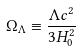Convert formula to latex. <formula><loc_0><loc_0><loc_500><loc_500>\Omega _ { \Lambda } \equiv \frac { \Lambda c ^ { 2 } } { 3 H _ { 0 } ^ { 2 } }</formula> 